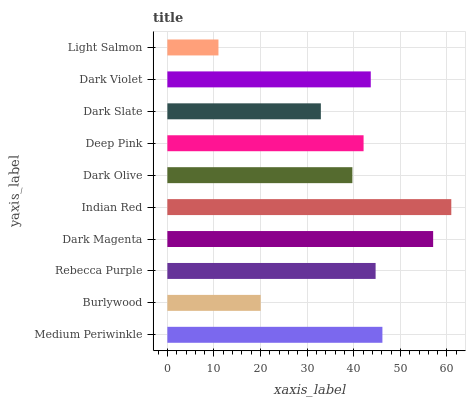Is Light Salmon the minimum?
Answer yes or no. Yes. Is Indian Red the maximum?
Answer yes or no. Yes. Is Burlywood the minimum?
Answer yes or no. No. Is Burlywood the maximum?
Answer yes or no. No. Is Medium Periwinkle greater than Burlywood?
Answer yes or no. Yes. Is Burlywood less than Medium Periwinkle?
Answer yes or no. Yes. Is Burlywood greater than Medium Periwinkle?
Answer yes or no. No. Is Medium Periwinkle less than Burlywood?
Answer yes or no. No. Is Dark Violet the high median?
Answer yes or no. Yes. Is Deep Pink the low median?
Answer yes or no. Yes. Is Indian Red the high median?
Answer yes or no. No. Is Burlywood the low median?
Answer yes or no. No. 